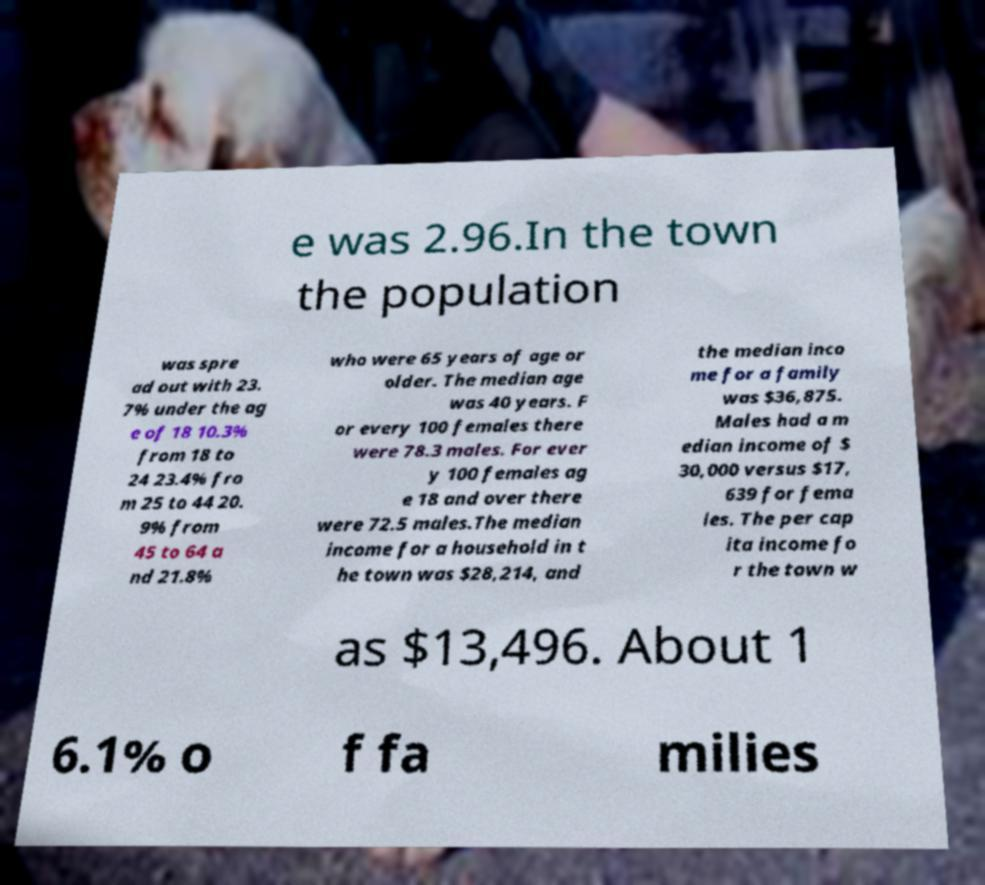There's text embedded in this image that I need extracted. Can you transcribe it verbatim? e was 2.96.In the town the population was spre ad out with 23. 7% under the ag e of 18 10.3% from 18 to 24 23.4% fro m 25 to 44 20. 9% from 45 to 64 a nd 21.8% who were 65 years of age or older. The median age was 40 years. F or every 100 females there were 78.3 males. For ever y 100 females ag e 18 and over there were 72.5 males.The median income for a household in t he town was $28,214, and the median inco me for a family was $36,875. Males had a m edian income of $ 30,000 versus $17, 639 for fema les. The per cap ita income fo r the town w as $13,496. About 1 6.1% o f fa milies 